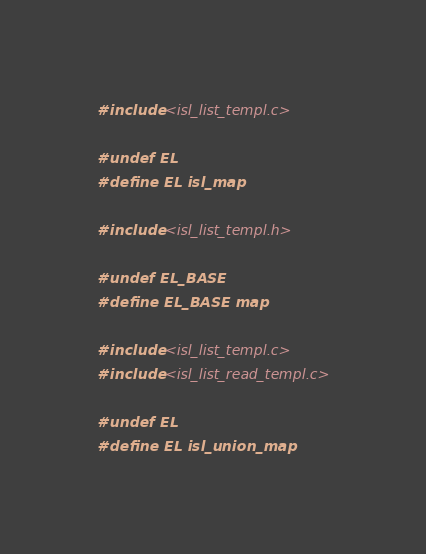Convert code to text. <code><loc_0><loc_0><loc_500><loc_500><_C_>#include <isl_list_templ.c>

#undef EL
#define EL isl_map

#include <isl_list_templ.h>

#undef EL_BASE
#define EL_BASE map

#include <isl_list_templ.c>
#include <isl_list_read_templ.c>

#undef EL
#define EL isl_union_map
</code> 